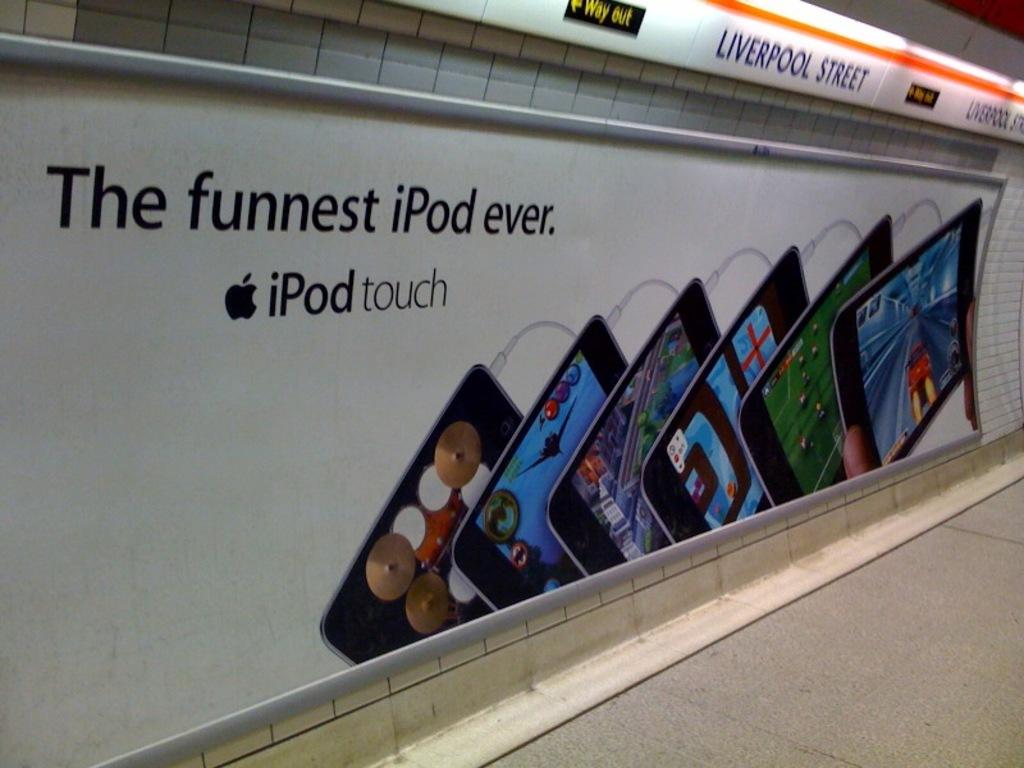Which ipod is this?
Your answer should be compact. Touch. Is this the funnest ipod ever?
Your answer should be very brief. Yes. 